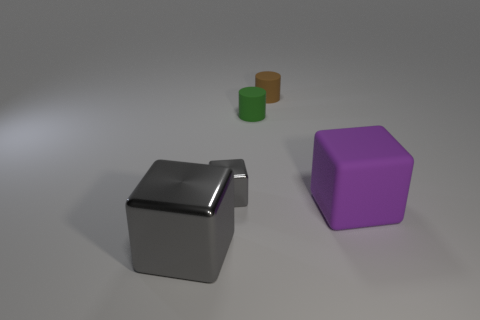What is the material of the other cube that is the same color as the small block?
Your answer should be compact. Metal. Do the green thing and the purple thing have the same size?
Offer a very short reply. No. What color is the rubber object that is both behind the matte cube and in front of the brown rubber thing?
Your answer should be compact. Green. The large object that is made of the same material as the small green cylinder is what shape?
Provide a succinct answer. Cube. What number of things are both to the right of the small metallic cube and behind the large purple thing?
Your answer should be compact. 2. There is a large gray cube; are there any objects to the right of it?
Provide a short and direct response. Yes. Do the matte thing on the right side of the small brown rubber cylinder and the gray shiny object that is behind the purple rubber block have the same shape?
Keep it short and to the point. Yes. How many things are big purple rubber objects or shiny blocks that are on the left side of the tiny block?
Offer a very short reply. 2. What number of other objects are there of the same shape as the purple matte thing?
Your answer should be very brief. 2. Is the large block that is left of the small brown cylinder made of the same material as the brown thing?
Ensure brevity in your answer.  No. 